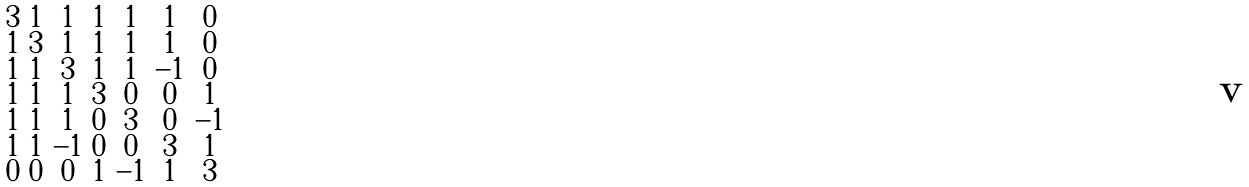Convert formula to latex. <formula><loc_0><loc_0><loc_500><loc_500>\begin{smallmatrix} 3 & 1 & 1 & 1 & 1 & 1 & 0 \\ 1 & 3 & 1 & 1 & 1 & 1 & 0 \\ 1 & 1 & 3 & 1 & 1 & - 1 & 0 \\ 1 & 1 & 1 & 3 & 0 & 0 & 1 \\ 1 & 1 & 1 & 0 & 3 & 0 & - 1 \\ 1 & 1 & - 1 & 0 & 0 & 3 & 1 \\ 0 & 0 & 0 & 1 & - 1 & 1 & 3 \end{smallmatrix}</formula> 